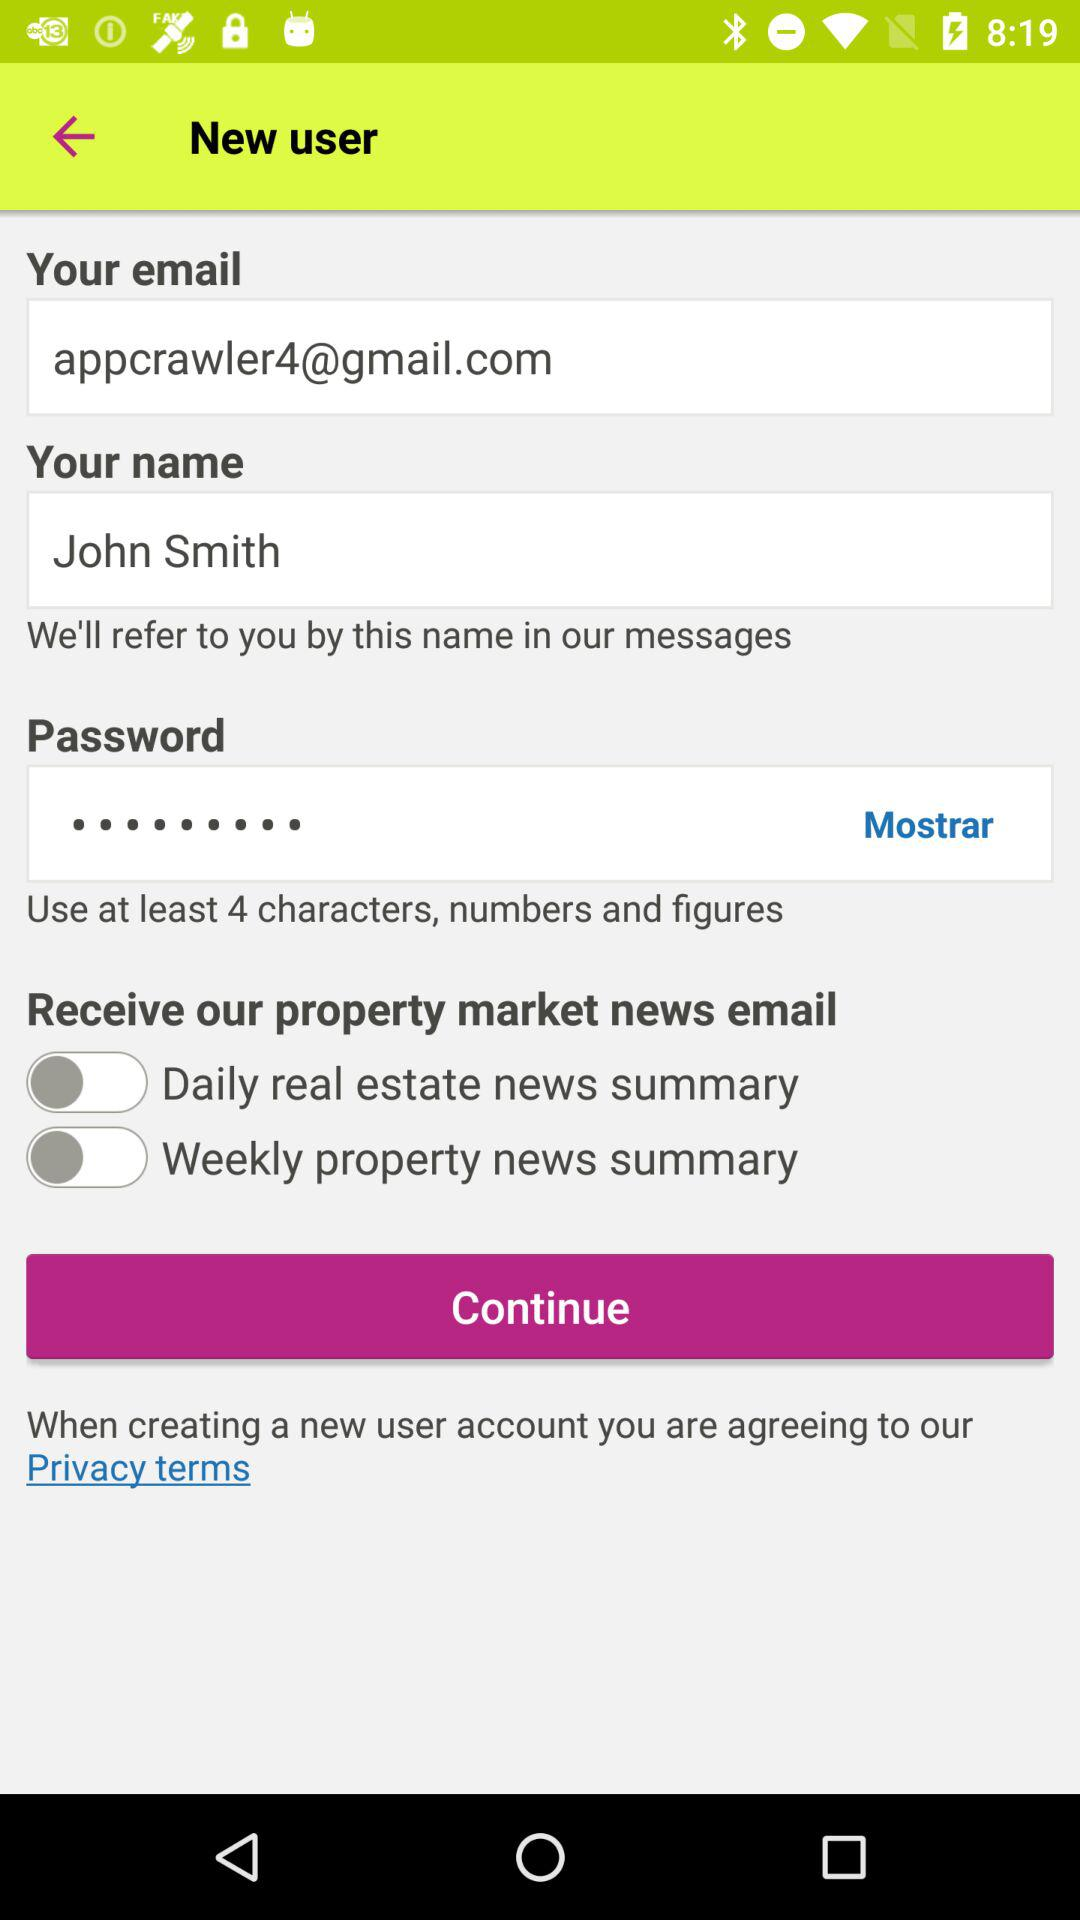How many input fields are there for personal information?
Answer the question using a single word or phrase. 3 